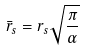<formula> <loc_0><loc_0><loc_500><loc_500>\bar { r } _ { s } = r _ { s } \sqrt { \frac { \pi } { \alpha } }</formula> 